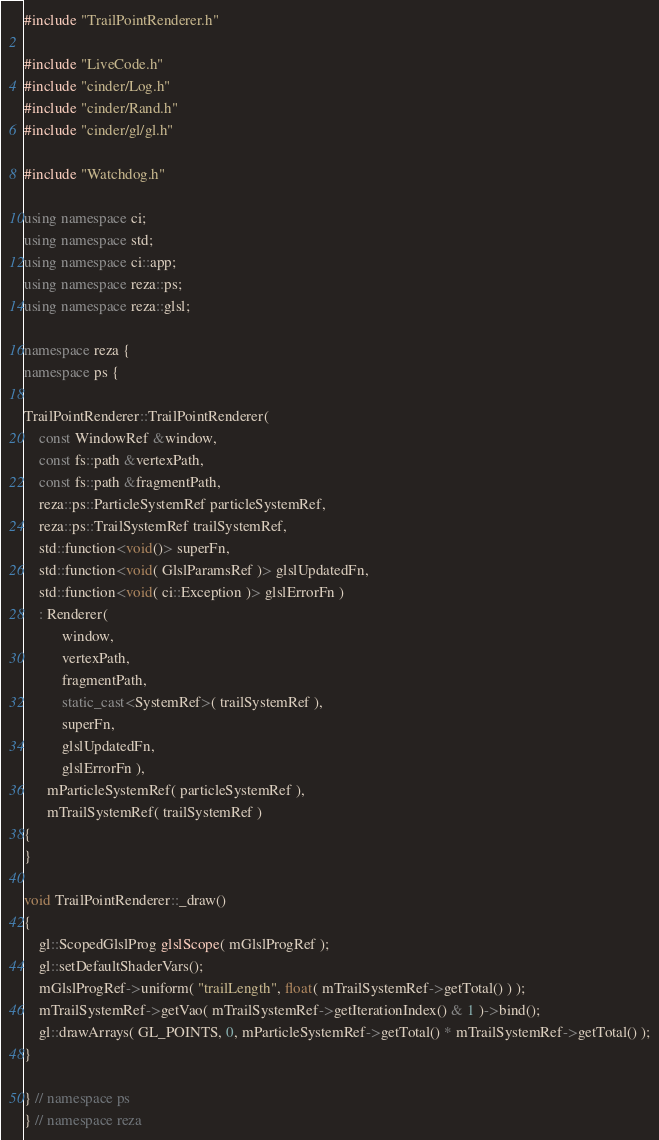<code> <loc_0><loc_0><loc_500><loc_500><_C++_>#include "TrailPointRenderer.h"

#include "LiveCode.h"
#include "cinder/Log.h"
#include "cinder/Rand.h"
#include "cinder/gl/gl.h"

#include "Watchdog.h"

using namespace ci;
using namespace std;
using namespace ci::app;
using namespace reza::ps;
using namespace reza::glsl;

namespace reza {
namespace ps {

TrailPointRenderer::TrailPointRenderer(
	const WindowRef &window,
	const fs::path &vertexPath,
	const fs::path &fragmentPath,
	reza::ps::ParticleSystemRef particleSystemRef,
	reza::ps::TrailSystemRef trailSystemRef,
	std::function<void()> superFn,
	std::function<void( GlslParamsRef )> glslUpdatedFn,
	std::function<void( ci::Exception )> glslErrorFn )
	: Renderer(
		  window,
		  vertexPath,
		  fragmentPath,
		  static_cast<SystemRef>( trailSystemRef ),
		  superFn,
		  glslUpdatedFn,
		  glslErrorFn ),
	  mParticleSystemRef( particleSystemRef ),
	  mTrailSystemRef( trailSystemRef )
{
}

void TrailPointRenderer::_draw()
{
	gl::ScopedGlslProg glslScope( mGlslProgRef );
	gl::setDefaultShaderVars();
	mGlslProgRef->uniform( "trailLength", float( mTrailSystemRef->getTotal() ) );
	mTrailSystemRef->getVao( mTrailSystemRef->getIterationIndex() & 1 )->bind();
	gl::drawArrays( GL_POINTS, 0, mParticleSystemRef->getTotal() * mTrailSystemRef->getTotal() );
}

} // namespace ps
} // namespace reza</code> 